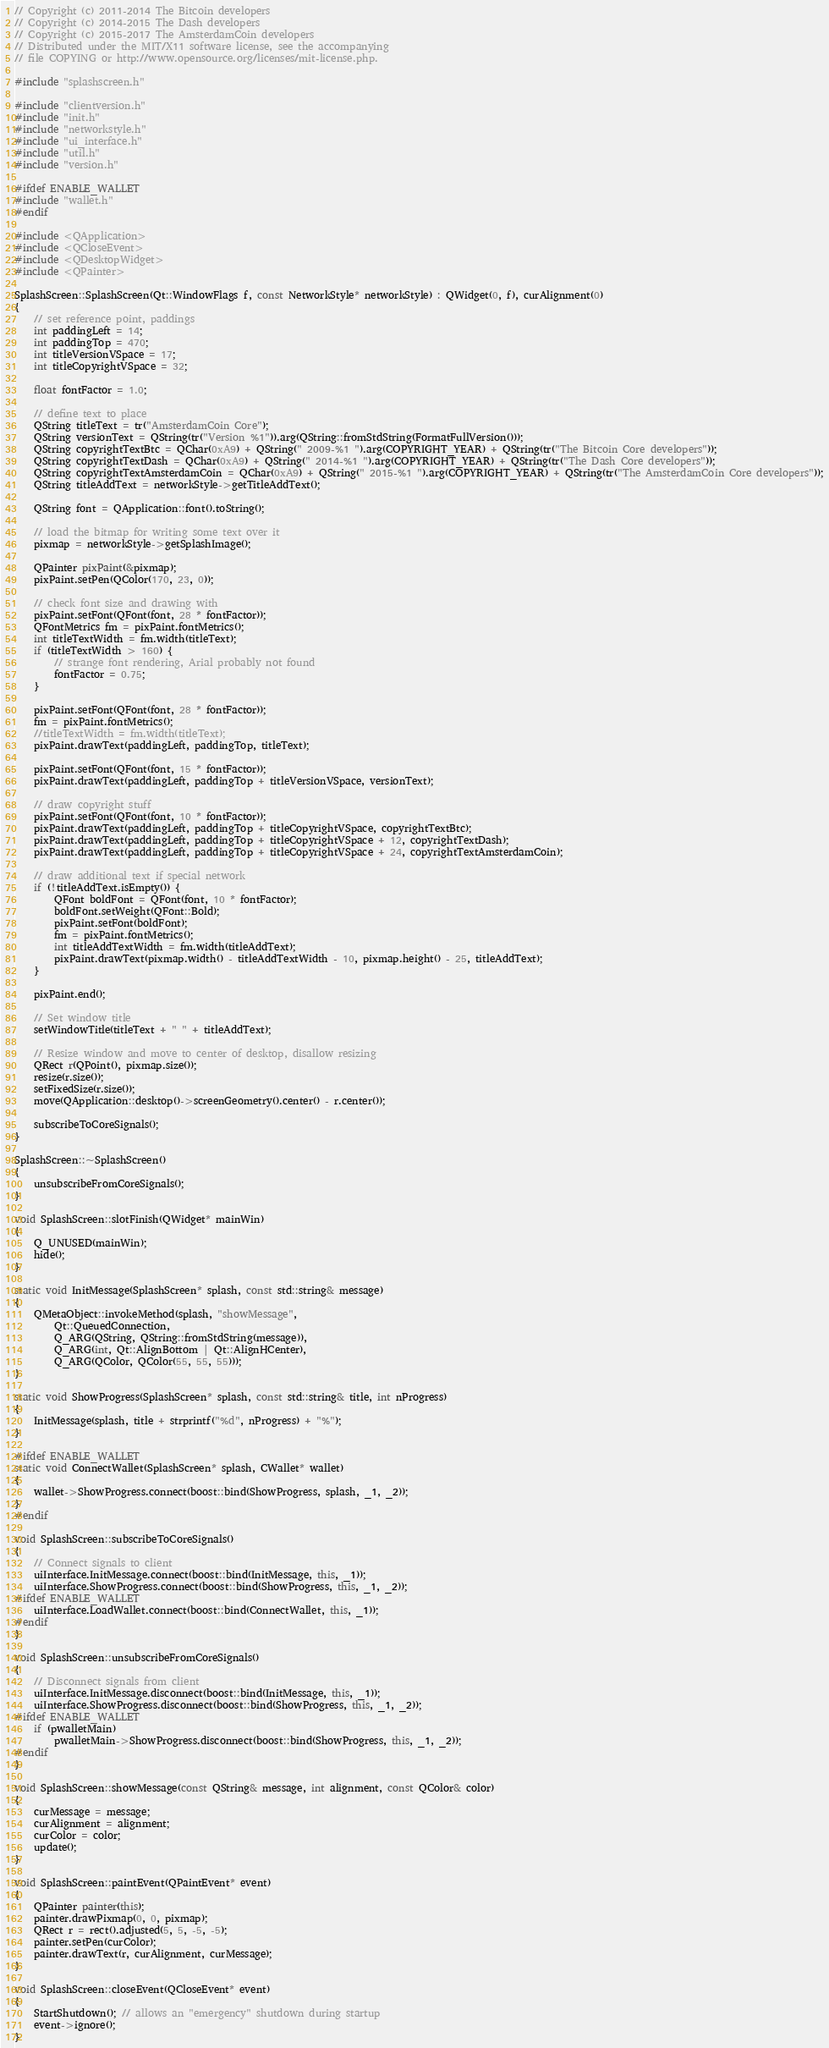<code> <loc_0><loc_0><loc_500><loc_500><_C++_>// Copyright (c) 2011-2014 The Bitcoin developers
// Copyright (c) 2014-2015 The Dash developers
// Copyright (c) 2015-2017 The AmsterdamCoin developers
// Distributed under the MIT/X11 software license, see the accompanying
// file COPYING or http://www.opensource.org/licenses/mit-license.php.

#include "splashscreen.h"

#include "clientversion.h"
#include "init.h"
#include "networkstyle.h"
#include "ui_interface.h"
#include "util.h"
#include "version.h"

#ifdef ENABLE_WALLET
#include "wallet.h"
#endif

#include <QApplication>
#include <QCloseEvent>
#include <QDesktopWidget>
#include <QPainter>

SplashScreen::SplashScreen(Qt::WindowFlags f, const NetworkStyle* networkStyle) : QWidget(0, f), curAlignment(0)
{
    // set reference point, paddings
    int paddingLeft = 14;
    int paddingTop = 470;
    int titleVersionVSpace = 17;
    int titleCopyrightVSpace = 32;

    float fontFactor = 1.0;

    // define text to place
    QString titleText = tr("AmsterdamCoin Core");
    QString versionText = QString(tr("Version %1")).arg(QString::fromStdString(FormatFullVersion()));
    QString copyrightTextBtc = QChar(0xA9) + QString(" 2009-%1 ").arg(COPYRIGHT_YEAR) + QString(tr("The Bitcoin Core developers"));
    QString copyrightTextDash = QChar(0xA9) + QString(" 2014-%1 ").arg(COPYRIGHT_YEAR) + QString(tr("The Dash Core developers"));
    QString copyrightTextAmsterdamCoin = QChar(0xA9) + QString(" 2015-%1 ").arg(COPYRIGHT_YEAR) + QString(tr("The AmsterdamCoin Core developers"));
    QString titleAddText = networkStyle->getTitleAddText();

    QString font = QApplication::font().toString();

    // load the bitmap for writing some text over it
    pixmap = networkStyle->getSplashImage();

    QPainter pixPaint(&pixmap);
    pixPaint.setPen(QColor(170, 23, 0));

    // check font size and drawing with
    pixPaint.setFont(QFont(font, 28 * fontFactor));
    QFontMetrics fm = pixPaint.fontMetrics();
    int titleTextWidth = fm.width(titleText);
    if (titleTextWidth > 160) {
        // strange font rendering, Arial probably not found
        fontFactor = 0.75;
    }

    pixPaint.setFont(QFont(font, 28 * fontFactor));
    fm = pixPaint.fontMetrics();
    //titleTextWidth = fm.width(titleText);
    pixPaint.drawText(paddingLeft, paddingTop, titleText);

    pixPaint.setFont(QFont(font, 15 * fontFactor));
    pixPaint.drawText(paddingLeft, paddingTop + titleVersionVSpace, versionText);

    // draw copyright stuff
    pixPaint.setFont(QFont(font, 10 * fontFactor));
    pixPaint.drawText(paddingLeft, paddingTop + titleCopyrightVSpace, copyrightTextBtc);
    pixPaint.drawText(paddingLeft, paddingTop + titleCopyrightVSpace + 12, copyrightTextDash);
    pixPaint.drawText(paddingLeft, paddingTop + titleCopyrightVSpace + 24, copyrightTextAmsterdamCoin);

    // draw additional text if special network
    if (!titleAddText.isEmpty()) {
        QFont boldFont = QFont(font, 10 * fontFactor);
        boldFont.setWeight(QFont::Bold);
        pixPaint.setFont(boldFont);
        fm = pixPaint.fontMetrics();
        int titleAddTextWidth = fm.width(titleAddText);
        pixPaint.drawText(pixmap.width() - titleAddTextWidth - 10, pixmap.height() - 25, titleAddText);
    }

    pixPaint.end();

    // Set window title
    setWindowTitle(titleText + " " + titleAddText);

    // Resize window and move to center of desktop, disallow resizing
    QRect r(QPoint(), pixmap.size());
    resize(r.size());
    setFixedSize(r.size());
    move(QApplication::desktop()->screenGeometry().center() - r.center());

    subscribeToCoreSignals();
}

SplashScreen::~SplashScreen()
{
    unsubscribeFromCoreSignals();
}

void SplashScreen::slotFinish(QWidget* mainWin)
{
    Q_UNUSED(mainWin);
    hide();
}

static void InitMessage(SplashScreen* splash, const std::string& message)
{
    QMetaObject::invokeMethod(splash, "showMessage",
        Qt::QueuedConnection,
        Q_ARG(QString, QString::fromStdString(message)),
        Q_ARG(int, Qt::AlignBottom | Qt::AlignHCenter),
        Q_ARG(QColor, QColor(55, 55, 55)));
}

static void ShowProgress(SplashScreen* splash, const std::string& title, int nProgress)
{
    InitMessage(splash, title + strprintf("%d", nProgress) + "%");
}

#ifdef ENABLE_WALLET
static void ConnectWallet(SplashScreen* splash, CWallet* wallet)
{
    wallet->ShowProgress.connect(boost::bind(ShowProgress, splash, _1, _2));
}
#endif

void SplashScreen::subscribeToCoreSignals()
{
    // Connect signals to client
    uiInterface.InitMessage.connect(boost::bind(InitMessage, this, _1));
    uiInterface.ShowProgress.connect(boost::bind(ShowProgress, this, _1, _2));
#ifdef ENABLE_WALLET
    uiInterface.LoadWallet.connect(boost::bind(ConnectWallet, this, _1));
#endif
}

void SplashScreen::unsubscribeFromCoreSignals()
{
    // Disconnect signals from client
    uiInterface.InitMessage.disconnect(boost::bind(InitMessage, this, _1));
    uiInterface.ShowProgress.disconnect(boost::bind(ShowProgress, this, _1, _2));
#ifdef ENABLE_WALLET
    if (pwalletMain)
        pwalletMain->ShowProgress.disconnect(boost::bind(ShowProgress, this, _1, _2));
#endif
}

void SplashScreen::showMessage(const QString& message, int alignment, const QColor& color)
{
    curMessage = message;
    curAlignment = alignment;
    curColor = color;
    update();
}

void SplashScreen::paintEvent(QPaintEvent* event)
{
    QPainter painter(this);
    painter.drawPixmap(0, 0, pixmap);
    QRect r = rect().adjusted(5, 5, -5, -5);
    painter.setPen(curColor);
    painter.drawText(r, curAlignment, curMessage);
}

void SplashScreen::closeEvent(QCloseEvent* event)
{
    StartShutdown(); // allows an "emergency" shutdown during startup
    event->ignore();
}
</code> 